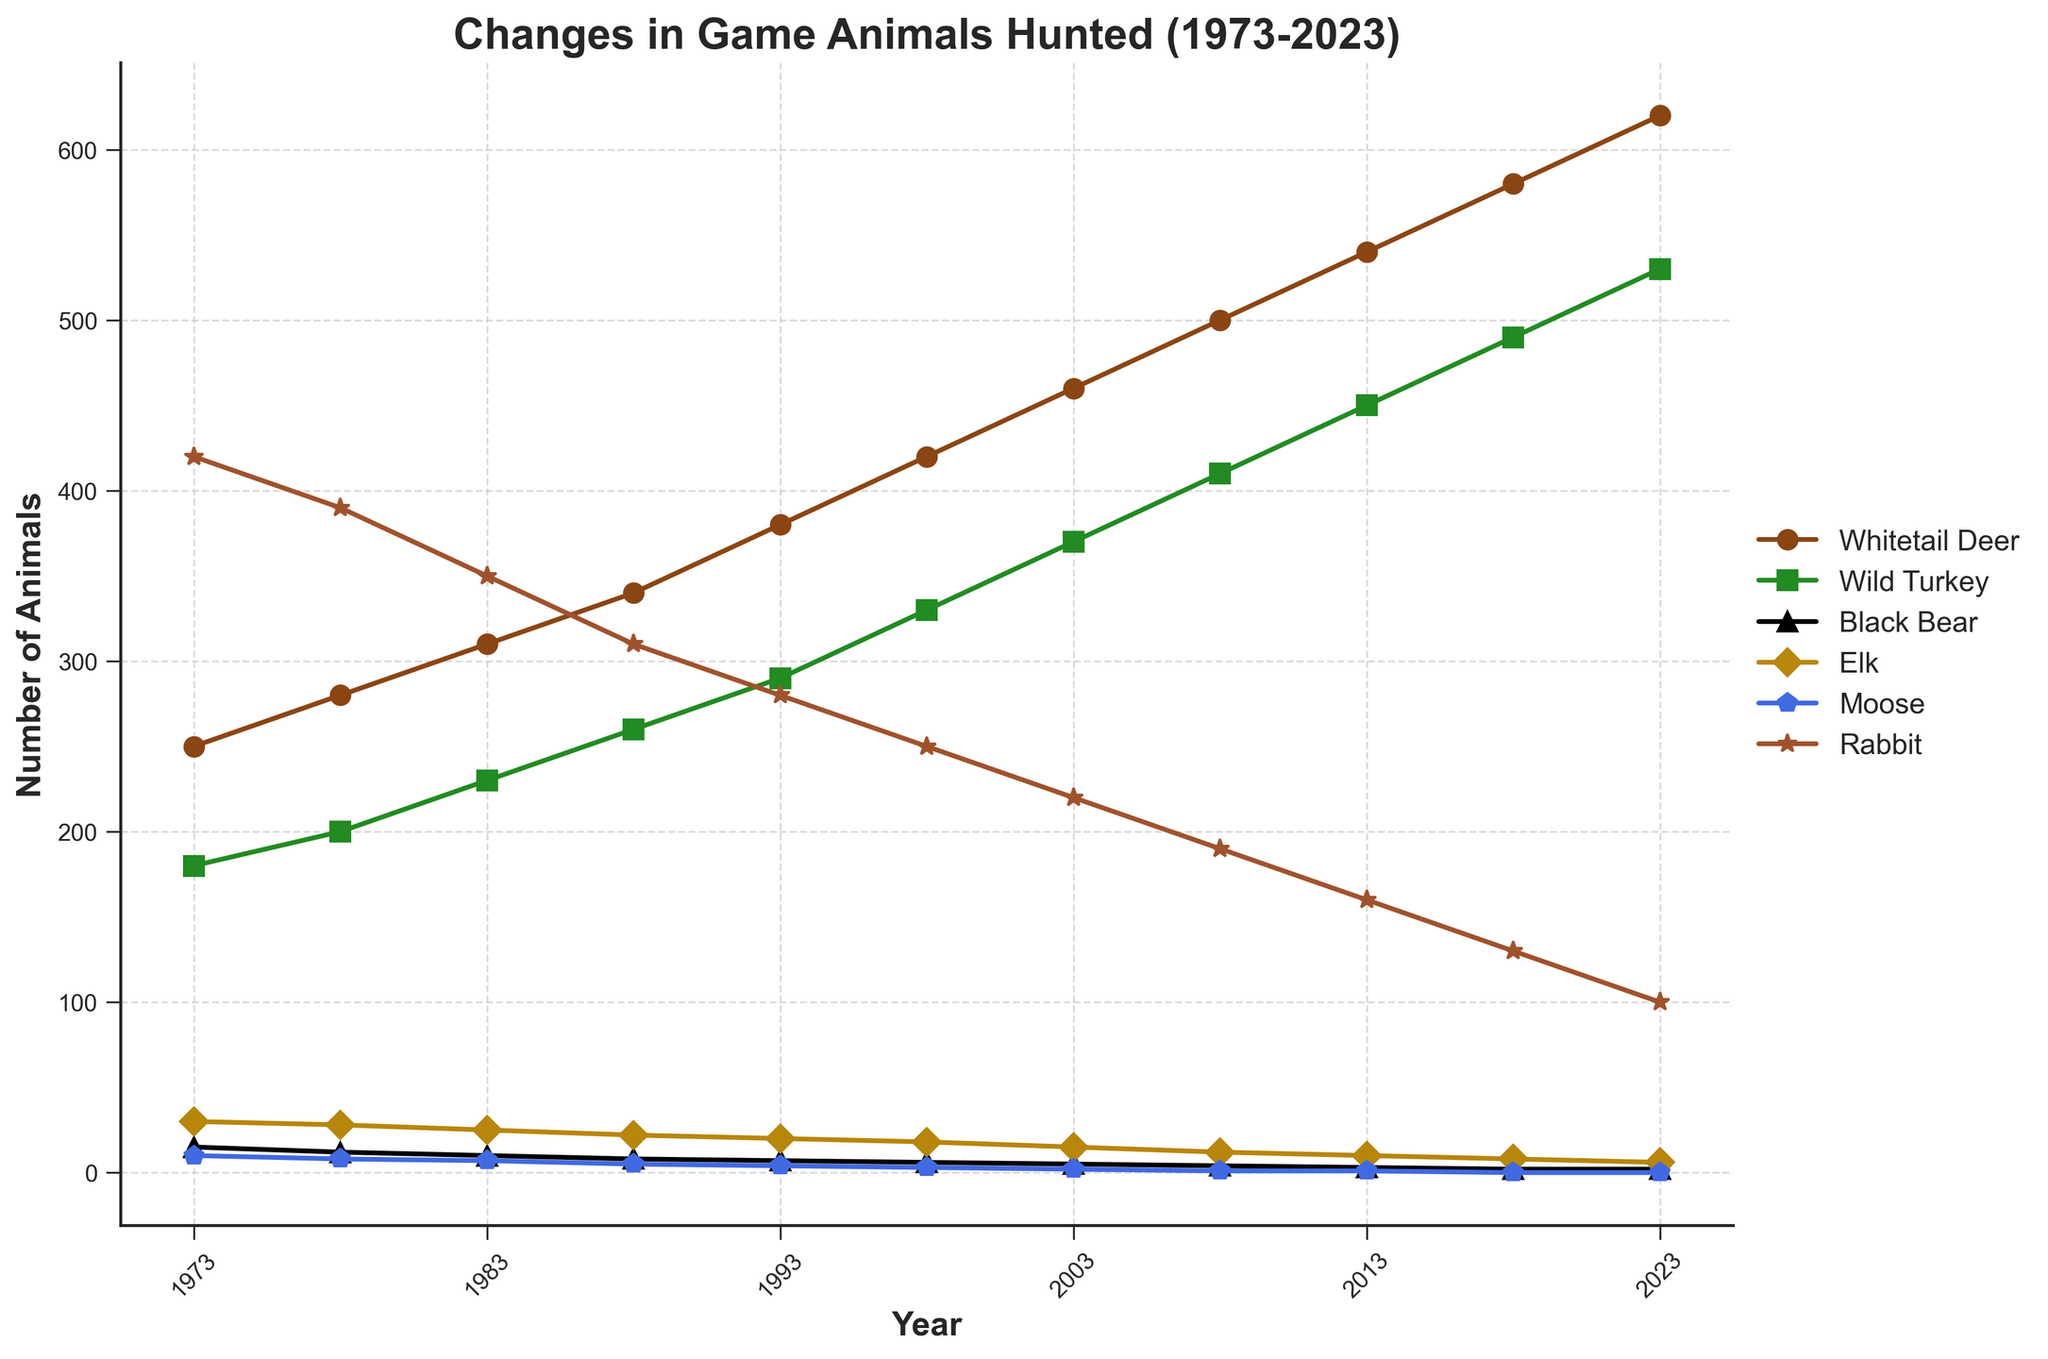What's the overall trend in the number of Whitetail Deer hunted from 1973 to 2023? The plot shows an increasing trend in the number of Whitetail Deer hunted over the 50-year span. Specific values indicate a rise from 250 in 1973 to 620 in 2023.
Answer: Increasing Which animal saw the largest decline in numbers from 1973 to 2023? The plot highlights that Rabbit saw the largest decline, dropping from 420 in 1973 to 100 in 2023.
Answer: Rabbit What is the difference between the number of Wild Turkeys hunted in 2023 and in 1973? From the plot, the number of Wild Turkeys hunted is 530 in 2023 and 180 in 1973. The difference is 530 - 180.
Answer: 350 Which two animals have the same number of individuals hunted in 2023? The plot shows that both Elk and Moose have 0 individuals hunted in 2023.
Answer: Elk and Moose How many animals were collectively hunted in 1983? The plot shows the following values for 1983: Whitetail Deer (310), Wild Turkey (230), Black Bear (10), Elk (25), Moose (7), Rabbit (350). The sum is 310 + 230 + 10 + 25 + 7 + 350.
Answer: 932 Is the number of Black Bears hunted greater in 1973 or 2023? According to the plot, in 1973, the number of Black Bears hunted was 15, and in 2023 it was 2. Therefore, more were hunted in 1973.
Answer: 1973 What is the median number of Whitetail Deer hunted over the years depicted in the plot? Organize the values of Whitetail Deer hunted (250, 280, 310, 340, 380, 420, 460, 500, 540, 580, 620) in ascending order and find the middle value, which is 420.
Answer: 420 Between which two consecutive years did the number of Wild Turkey hunted increase the most? Observing the plot reveals that the largest jump in the Wild Turkey count occurred between 2018 (490) and 2023 (530). The increase is 530 - 490.
Answer: 2018 and 2023 Comparing 1988 and 1998, which animal shows the most significant numerical decrease? The plot shows the following decrases: Rabbit from 310 to 250, a decrease of 60; Black Bear from 8 to 6, a decrease of 2; Wild Turkey from 260 to 330, an increase; Whitetail Deer from 340 to 420, an increase; Elk from 22 to 18, a decrease of 4; Moose from 5 to 3, a decrease of 2. The most significant decrease comes from Rabbit.
Answer: Rabbit Has the trend in the number of Rabits hunted been decreasing, increasing, or stable across the given period? Analyzing the trend from the plot shows a consistent decrease from 420 in 1973 to 100 in 2023.
Answer: Decreasing 